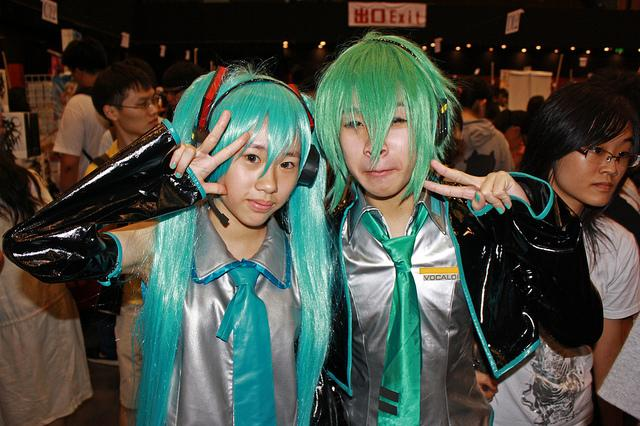What hand gesture are the two doing? peace 